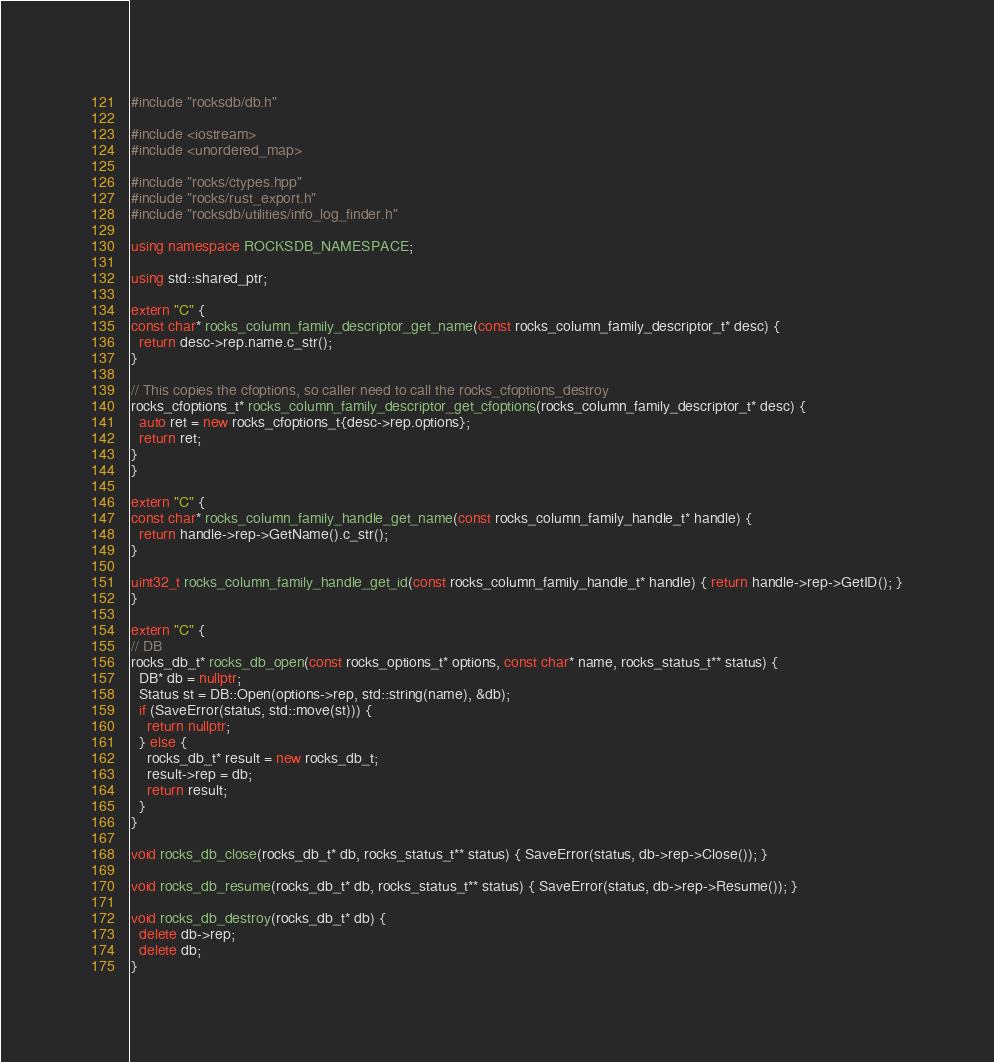<code> <loc_0><loc_0><loc_500><loc_500><_C++_>#include "rocksdb/db.h"

#include <iostream>
#include <unordered_map>

#include "rocks/ctypes.hpp"
#include "rocks/rust_export.h"
#include "rocksdb/utilities/info_log_finder.h"

using namespace ROCKSDB_NAMESPACE;

using std::shared_ptr;

extern "C" {
const char* rocks_column_family_descriptor_get_name(const rocks_column_family_descriptor_t* desc) {
  return desc->rep.name.c_str();
}

// This copies the cfoptions, so caller need to call the rocks_cfoptions_destroy
rocks_cfoptions_t* rocks_column_family_descriptor_get_cfoptions(rocks_column_family_descriptor_t* desc) {
  auto ret = new rocks_cfoptions_t{desc->rep.options};
  return ret;
}
}

extern "C" {
const char* rocks_column_family_handle_get_name(const rocks_column_family_handle_t* handle) {
  return handle->rep->GetName().c_str();
}

uint32_t rocks_column_family_handle_get_id(const rocks_column_family_handle_t* handle) { return handle->rep->GetID(); }
}

extern "C" {
// DB
rocks_db_t* rocks_db_open(const rocks_options_t* options, const char* name, rocks_status_t** status) {
  DB* db = nullptr;
  Status st = DB::Open(options->rep, std::string(name), &db);
  if (SaveError(status, std::move(st))) {
    return nullptr;
  } else {
    rocks_db_t* result = new rocks_db_t;
    result->rep = db;
    return result;
  }
}

void rocks_db_close(rocks_db_t* db, rocks_status_t** status) { SaveError(status, db->rep->Close()); }

void rocks_db_resume(rocks_db_t* db, rocks_status_t** status) { SaveError(status, db->rep->Resume()); }

void rocks_db_destroy(rocks_db_t* db) {
  delete db->rep;
  delete db;
}
</code> 